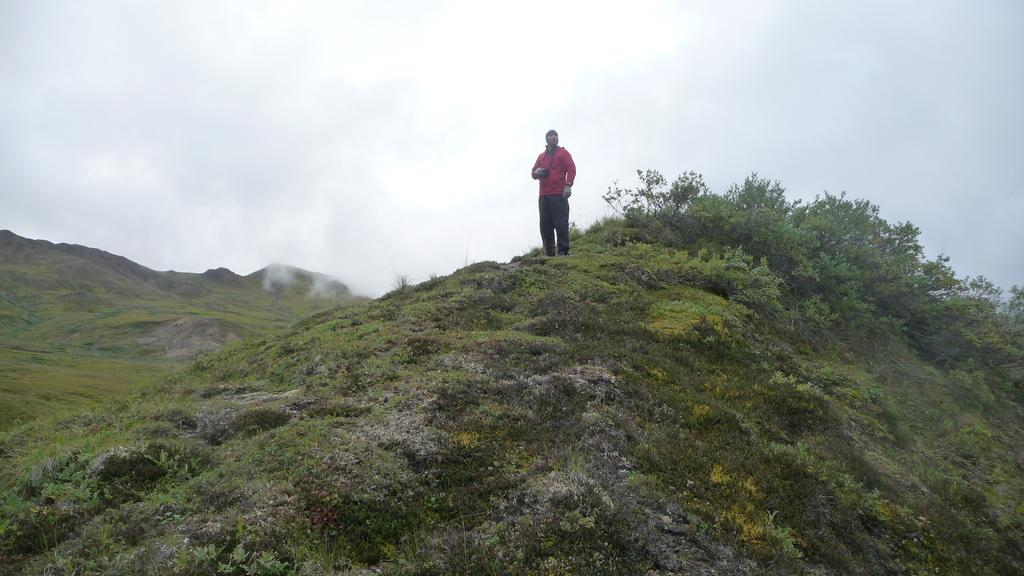Who is present in the image? There is a man in the image. What is the man wearing? The man is wearing a red jacket. Where is the man standing? The man is standing on a path. What can be seen in the image besides the man? There are plants, fog, hills, and the sky visible in the image. What type of wax can be seen melting on the man's heart in the image? There is no wax or heart present in the image; it features a man standing on a path with plants, fog, hills, and the sky visible in the background. 